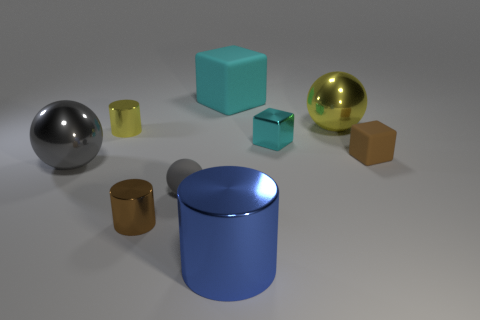Subtract 0 green cubes. How many objects are left? 9 Subtract all cylinders. How many objects are left? 6 Subtract 1 cylinders. How many cylinders are left? 2 Subtract all red cylinders. Subtract all yellow balls. How many cylinders are left? 3 Subtract all gray cylinders. How many yellow cubes are left? 0 Subtract all big yellow cylinders. Subtract all tiny gray matte balls. How many objects are left? 8 Add 2 cylinders. How many cylinders are left? 5 Add 1 small brown metal cylinders. How many small brown metal cylinders exist? 2 Subtract all gray balls. How many balls are left? 1 Subtract all tiny gray balls. How many balls are left? 2 